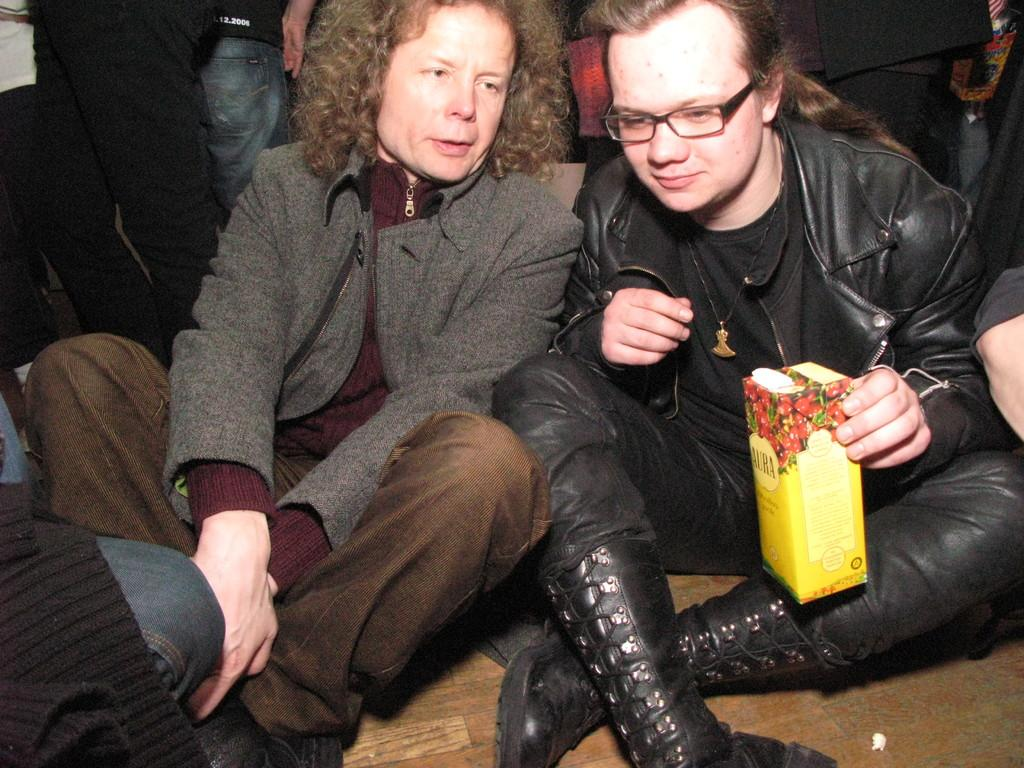What are the two people in the center of the image doing? The two people are sitting on the floor in the center of the image. Can you describe the people in the background of the image? There are people visible in the background of the image, but their specific actions or characteristics are not mentioned in the provided facts. What type of quilt is being used by the monkey in the image? There is no monkey or quilt present in the image. 